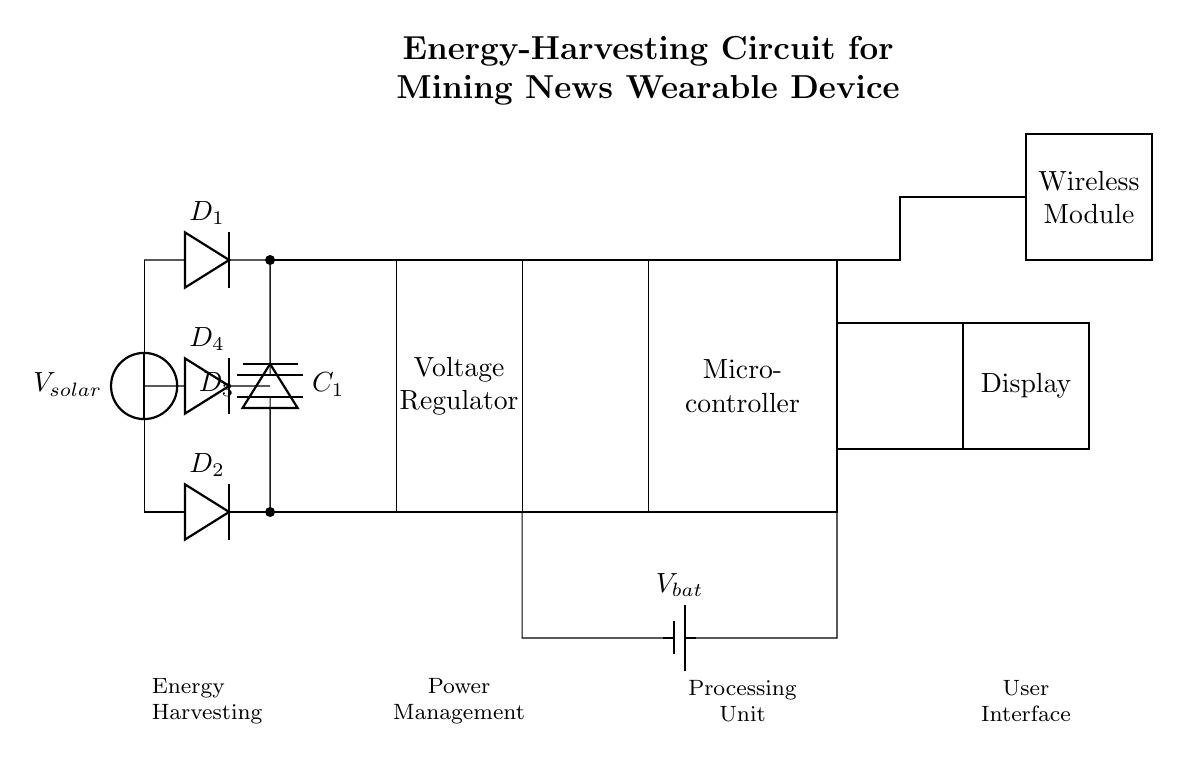What is the main energy source in this circuit? The main energy source is indicated by the voltage source labeled V_{solar}, which provides power to the circuit through solar energy.
Answer: V_{solar} How many diodes are used in the circuit? The diagram shows four diodes labeled D_1, D_2, D_3, and D_4. The count of diodes can be determined by simply counting the distinct diode symbols on the diagram.
Answer: 4 What is the role of the capacitor in this circuit? The capacitor labeled C_1 serves to smooth out the output voltage from the rectifier by storing charge and releasing it when needed, which helps to provide a stable voltage to the subsequent components.
Answer: Smoothing Which component regulates the voltage? The voltage regulator block labeled as "Voltage Regulator" is designed to maintain a constant output voltage despite variations in input voltage or load conditions. This is crucial in ensuring that the microcontroller and other components operate reliably.
Answer: Voltage Regulator What is the purpose of the wireless module? The wireless module, labeled accordingly in the diagram, is responsible for enabling the wearable device to communicate wirelessly, likely to send or receive mining news and updates. This function is essential for the device's overall operation as a news monitor.
Answer: Communication What is the function of the microcontroller in this circuit? The microcontroller, labeled in the diagram, acts as the processing unit that controls the functioning of the entire circuit. It processes data, sends commands to other components, and manages user interactions, making it a central part of the device's operation.
Answer: Processing Is there a backup power source in this circuit? Yes, the circuit features a battery labeled as V_{bat}, which serves as a backup power source. It ensures that the device remains operational even when solar energy is insufficient, thus increasing the reliability of the wearable device.
Answer: Yes 